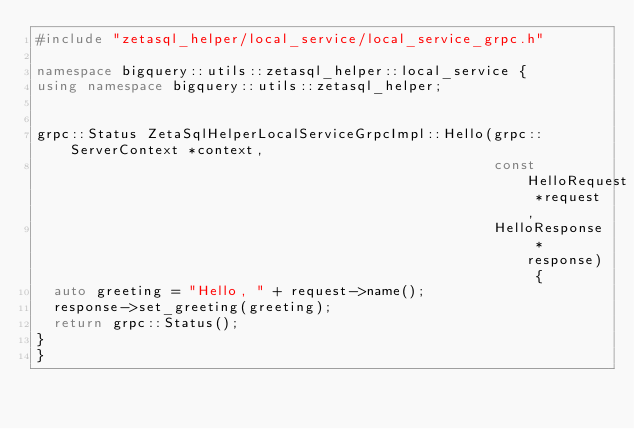<code> <loc_0><loc_0><loc_500><loc_500><_C++_>#include "zetasql_helper/local_service/local_service_grpc.h"

namespace bigquery::utils::zetasql_helper::local_service {
using namespace bigquery::utils::zetasql_helper;


grpc::Status ZetaSqlHelperLocalServiceGrpcImpl::Hello(grpc::ServerContext *context,
                                                      const HelloRequest *request,
                                                      HelloResponse *response) {
  auto greeting = "Hello, " + request->name();
  response->set_greeting(greeting);
  return grpc::Status();
}
}
</code> 